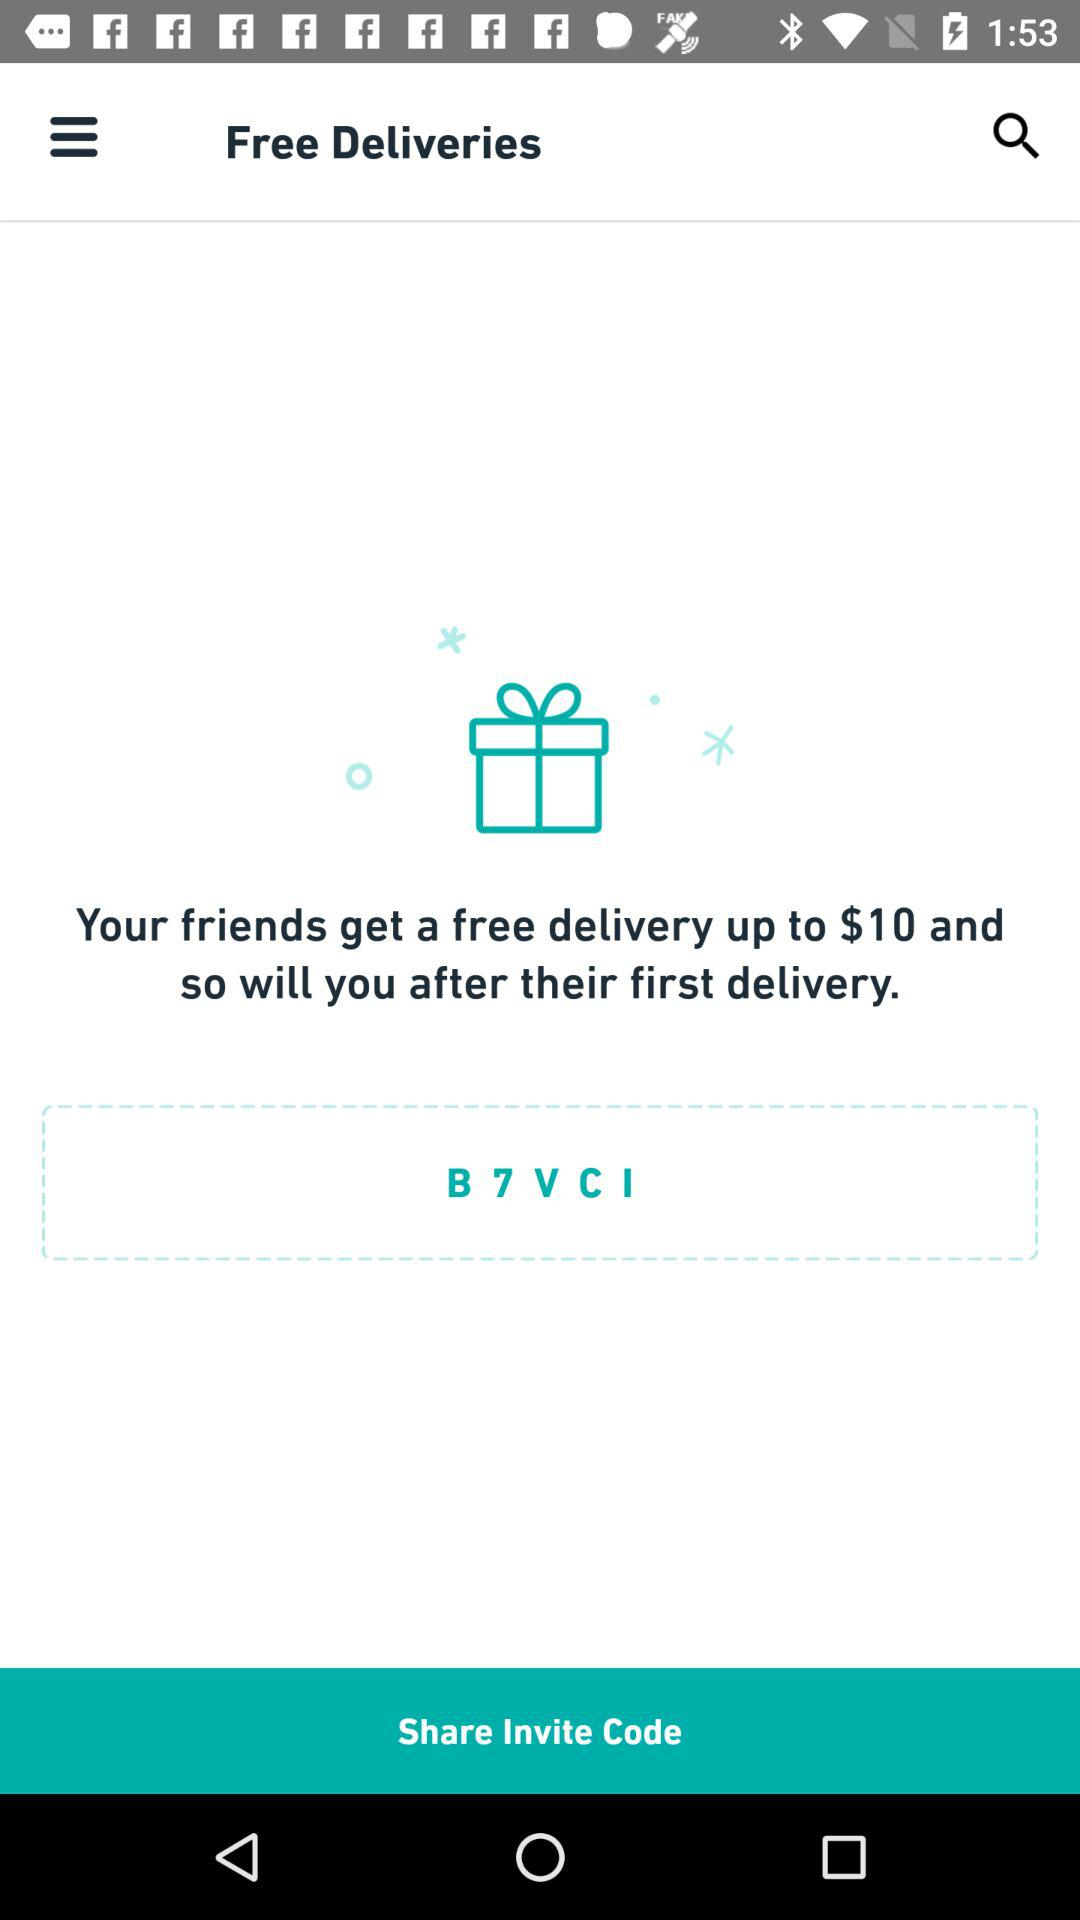Up to what amount is free delivery applicable? Free delivery is applicable up to $10. 